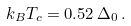<formula> <loc_0><loc_0><loc_500><loc_500>k _ { B } T _ { c } = 0 . 5 2 \, \Delta _ { 0 } \, .</formula> 